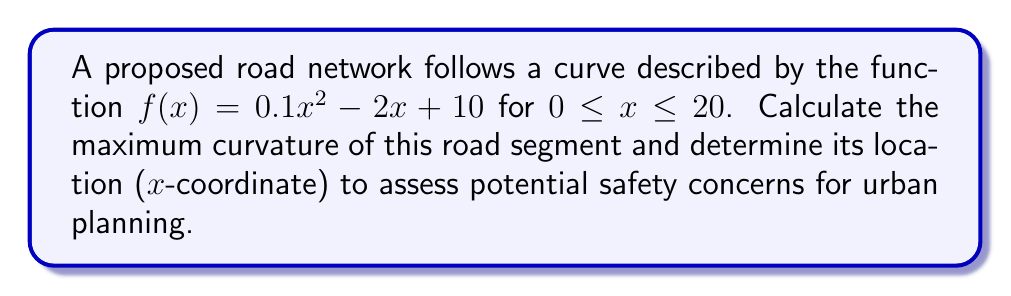Give your solution to this math problem. To solve this problem, we'll follow these steps:

1) The curvature of a function $y = f(x)$ is given by the formula:

   $$\kappa = \frac{|f''(x)|}{(1 + (f'(x))^2)^{3/2}}$$

2) First, let's find $f'(x)$ and $f''(x)$:
   
   $f'(x) = 0.2x - 2$
   $f''(x) = 0.2$

3) Substitute these into the curvature formula:

   $$\kappa = \frac{|0.2|}{(1 + (0.2x - 2)^2)^{3/2}}$$

4) The maximum curvature will occur where the denominator is at its minimum. The denominator is minimized when $0.2x - 2 = 0$, or $x = 10$.

5) Calculate the maximum curvature by substituting $x = 10$:

   $$\kappa_{max} = \frac{0.2}{(1 + 0^2)^{3/2}} = 0.2$$

6) To verify this is indeed the maximum, we can check values on either side of $x = 10$. The curvature will be less for any other x-value in the given range.

7) The location of the maximum curvature is at $x = 10$.
Answer: Maximum curvature: 0.2; Location: x = 10 